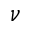Convert formula to latex. <formula><loc_0><loc_0><loc_500><loc_500>\nu</formula> 